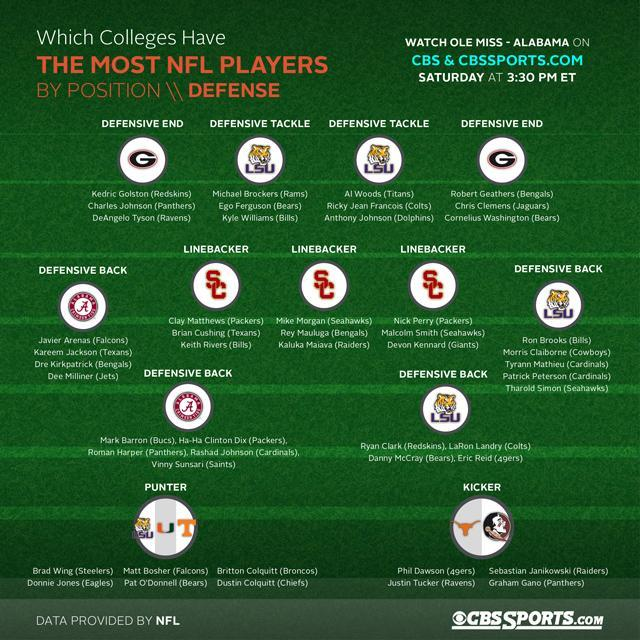Which team does the second line backer playing in the center belong to ?
Answer the question with a short phrase. Bengals Which college is the Kicker Sebastian Janikowki from, University of Texas, Florida State University, or Louisiana State University ?? Florida State University Which college does most defensive tackle and defensive back come from? Louisiana State University Which college did the defensive back on the left side come from, Alabama, Georgia, or Louisiana? Alabama Which team does the third line backer playing on the left belong to? Bills Which college are the defensive ends from Alabama, Georgia, or Louisiana? Georgia Name the second defensive end playing on the right side? Chris Clemens Name the fourth player playing as the defensive back on the right side? Patrick Peterson Which university regions do the Punters belong to? Louisiana, Miami, Tennessee Which college are the line backers from Alabama, Southern California, Georgia, or Louisiana? Southern California 